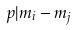<formula> <loc_0><loc_0><loc_500><loc_500>p | m _ { i } - m _ { j }</formula> 